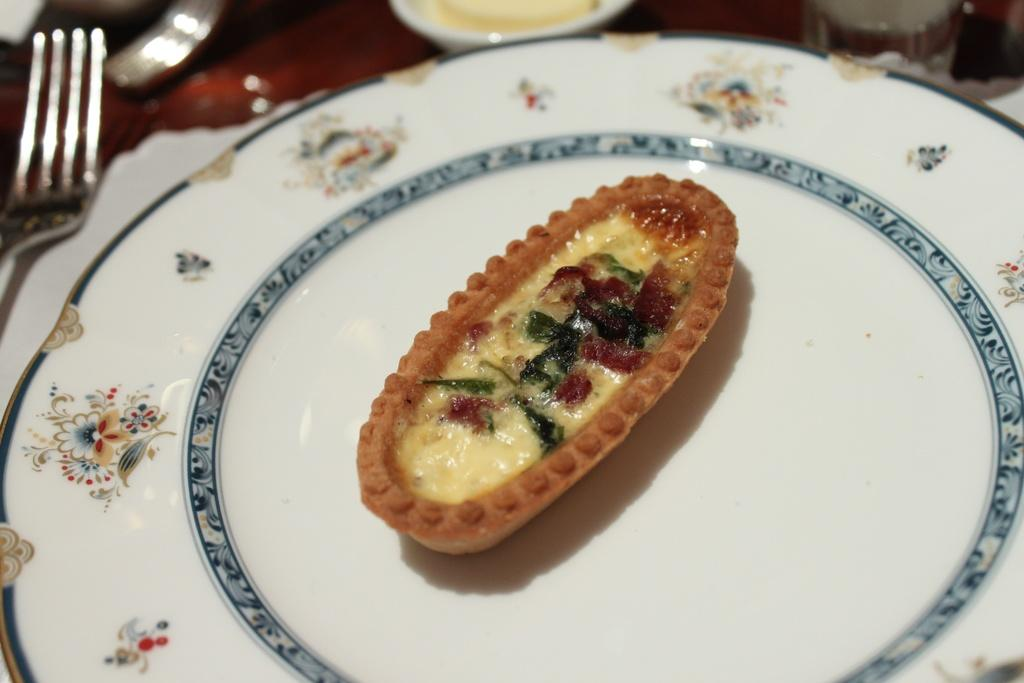What piece of furniture is present in the image? There is a table in the image. What is placed on the table? There is a plate, a fork, a cup, and food in the plate on the table. What utensil can be seen on the table? There is a fork on the table. What type of dishware is present on the table? There is a cup on the table. What is the condition of the background in the image? The background of the image is blurry. What time of day is depicted in the image? The provided facts do not mention the time of day, so it cannot be determined from the image. Can you see any smoke coming from the food in the image? There is no smoke present in the image; it only shows a table with a plate, fork, cup, and food. 